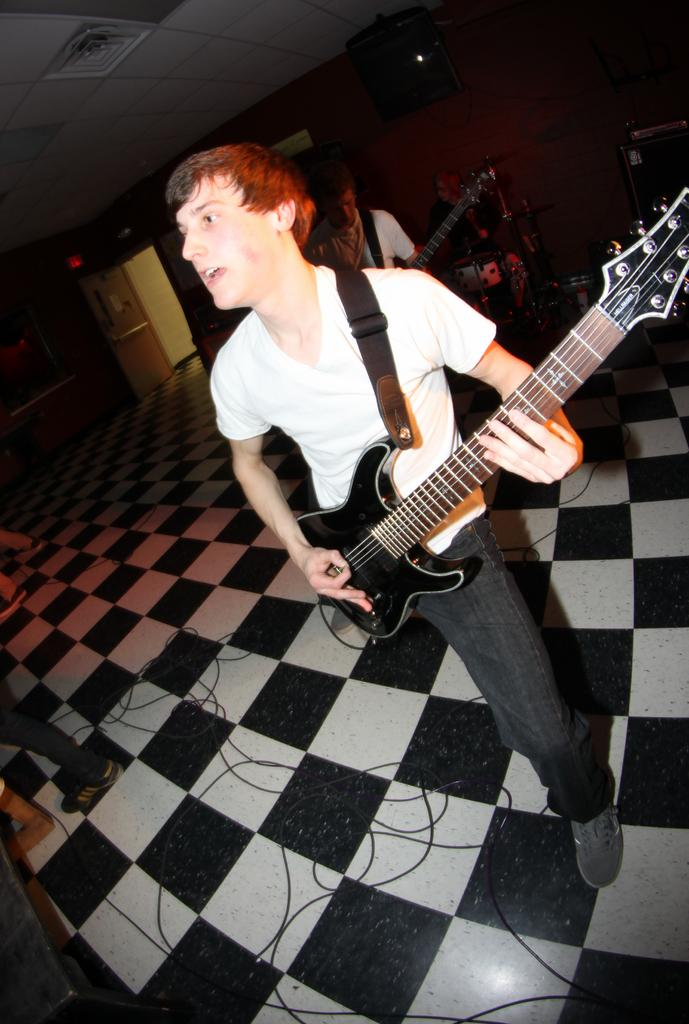What is the man in the image doing? The man is playing a guitar in the image. Are there any other musicians in the image? Yes, there are other people playing musical instruments in the image. What can be seen in the background of the image? There is a wall visible in the image. Can you tell me how many times the man whistles while playing the guitar in the image? There is no indication in the image that the man is whistling while playing the guitar. 